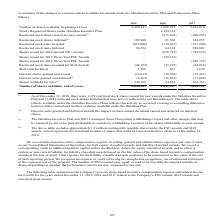According to Sealed Air Corporation's financial document, What does the table represent? summary of the changes in common shares available for awards under the Omnibus Incentive Plan and Predecessor Plans. The document states: "A summary of the changes in common shares available for awards under the Omnibus Incentive Plan and Predecessor Plans follows:..." Also, How many restricted stock shares were issued for new awards under the Omnibus Incentive Plan as of December 31, 2018? According to the financial document, 1,478. The relevant text states: "(1) As of December 31, 2018, there were 1,478 restricted stock shares issued for new awards under the Omnibus Incentive Plan and (5,024) restrict..." Also, What does the Omnibus Incentive Plan and 2005 Contingent Stock Plan permit? withholding of taxes and other charges that may be required by law to be paid attributable to awards by withholding a portion of the shares attributable to such awards. The document states: "entive Plan and 2005 Contingent Stock Plan permit withholding of taxes and other charges that may be required by law to be paid attributable to awards..." Also, can you calculate: What is the percentage difference of shares withheld for taxes for 2018 to 2019? To answer this question, I need to perform calculations using the financial data. The calculation is: (249,368-94,624)/94,624, which equals 163.54 (percentage). This is based on the information: ") (17,008) Shares withheld for taxes (3) 249,368 94,624 101,767 (16,505 ) (17,008) Shares withheld for taxes (3) 249,368 94,624 101,767..." The key data points involved are: 249,368, 94,624. Also, can you calculate: What is the Number of shares available, end of year expressed as a percentage of Number of shares available, beginning of year for 2019?  Based on the calculation: 4,048,509/4,489,347, the result is 90.18 (percentage). This is based on the information: "017 Number of shares available, beginning of year 4,489,347 3,668,954 5,385,870 Number of shares available, end of year (4) 4,048,509 4,489,347 3,668,954..." The key data points involved are: 4,048,509, 4,489,347. Also, can you calculate: What is the average annual Number of shares available, end of year for 2017-2019? To answer this question, I need to perform calculations using the financial data. The calculation is: (4,048,509+4,489,347+3,668,954)/3, which equals 4068936.67. This is based on the information: "017 Number of shares available, beginning of year 4,489,347 3,668,954 5,385,870 Number of shares available, end of year (4) 4,048,509 4,489,347 3,668,954 of shares available, beginning of year 4,489,3..." The key data points involved are: 3,668,954, 4,048,509, 4,489,347. 